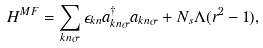Convert formula to latex. <formula><loc_0><loc_0><loc_500><loc_500>H ^ { M F } = \sum _ { k n \sigma } \epsilon _ { k n } a _ { k n \sigma } ^ { \dagger } a _ { k n \sigma } + N _ { s } \Lambda ( r ^ { 2 } - 1 ) ,</formula> 